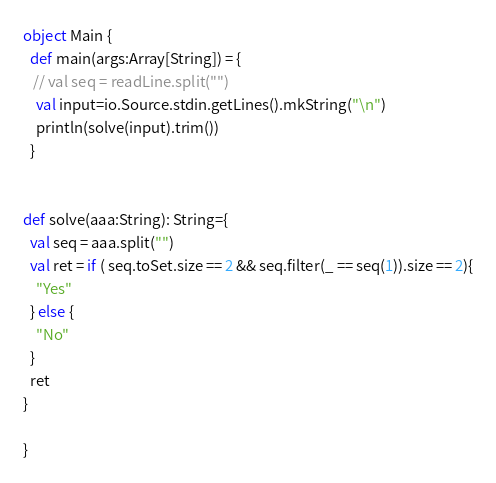<code> <loc_0><loc_0><loc_500><loc_500><_Scala_>object Main {
  def main(args:Array[String]) = {
   // val seq = readLine.split("")
    val input=io.Source.stdin.getLines().mkString("\n")
    println(solve(input).trim())
  }


def solve(aaa:String): String={
  val seq = aaa.split("")
  val ret = if ( seq.toSet.size == 2 && seq.filter(_ == seq(1)).size == 2){
    "Yes"
  } else {
    "No"
  }
  ret
}

}
</code> 